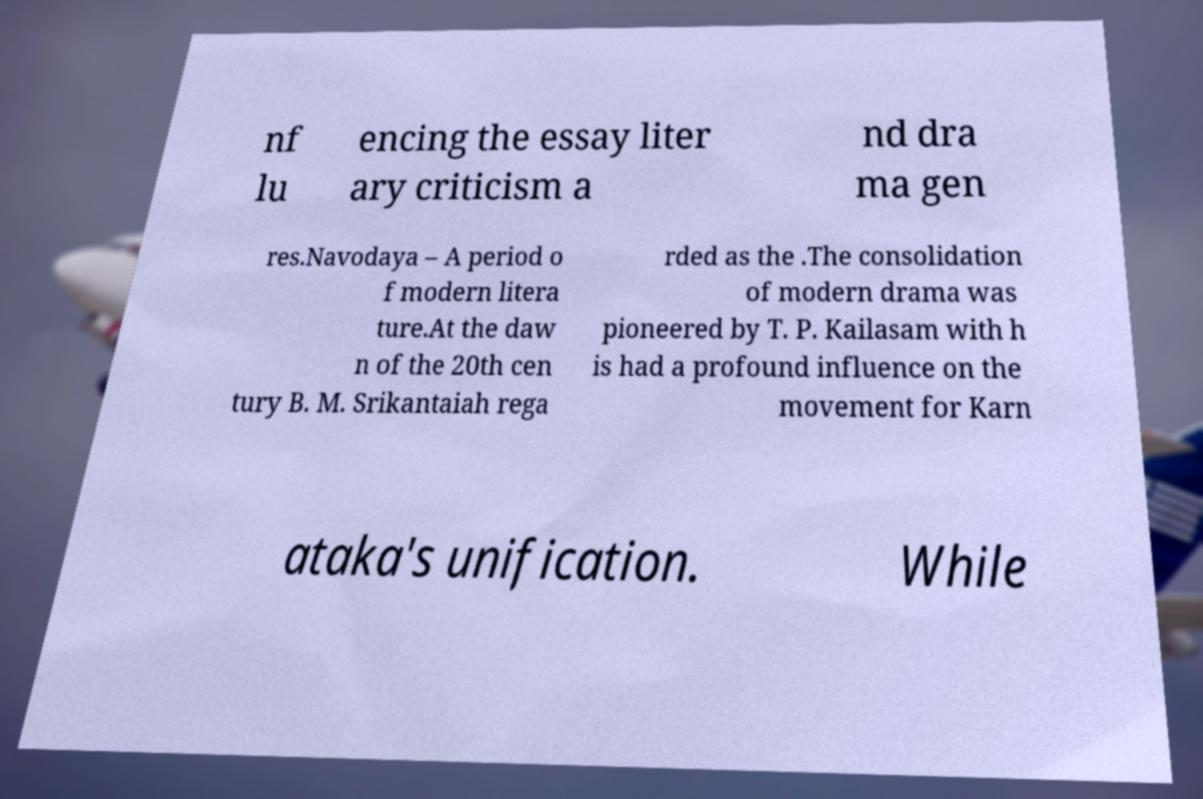For documentation purposes, I need the text within this image transcribed. Could you provide that? nf lu encing the essay liter ary criticism a nd dra ma gen res.Navodaya – A period o f modern litera ture.At the daw n of the 20th cen tury B. M. Srikantaiah rega rded as the .The consolidation of modern drama was pioneered by T. P. Kailasam with h is had a profound influence on the movement for Karn ataka's unification. While 